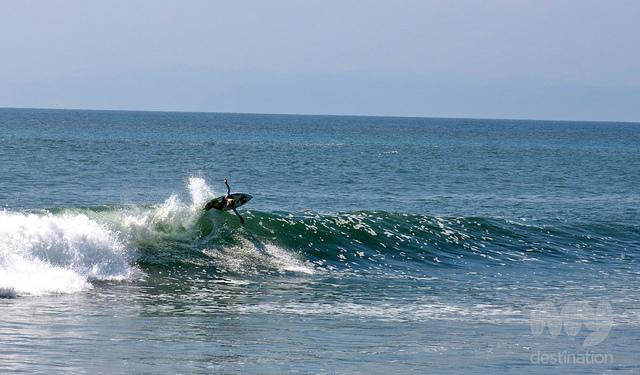Is somebody surfing?
Quick response, please. Yes. Is the water salty?
Concise answer only. Yes. Sunny or overcast?
Keep it brief. Sunny. 